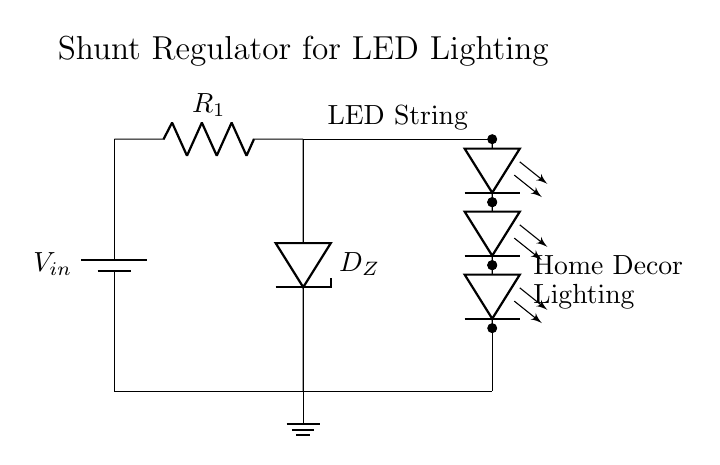What is the power supply in this circuit? The circuit diagram includes a battery component labeled V_in, which serves as the power supply for the circuit.
Answer: V_in What component regulates the LED's voltage? The Zener diode, marked as D_Z, is responsible for regulating the voltage to the LED string by providing a stable voltage reference across its terminals.
Answer: D_Z How many LEDs are in the string? The circuit shows a series of four LED components marked as LED string, indicating that there are four LEDs connected in series.
Answer: Four What role does the resistor play in this circuit? The resistor, labeled R_1, limits the current flowing through the circuit, preventing excess current from damaging the LED string or the Zener diode.
Answer: Current limiting What is the function of the ground in this circuit? The ground provides a reference point for the electrical potential in the circuit, allowing the current to return to the power supply and ensuring proper operation of the circuit.
Answer: Reference point What would happen if the Zener diode failed? If the Zener diode failed, it could result in either an open circuit or excessive current flowing to the LED string, potentially damaging the LEDs due to overvoltage.
Answer: Damage to LEDs 